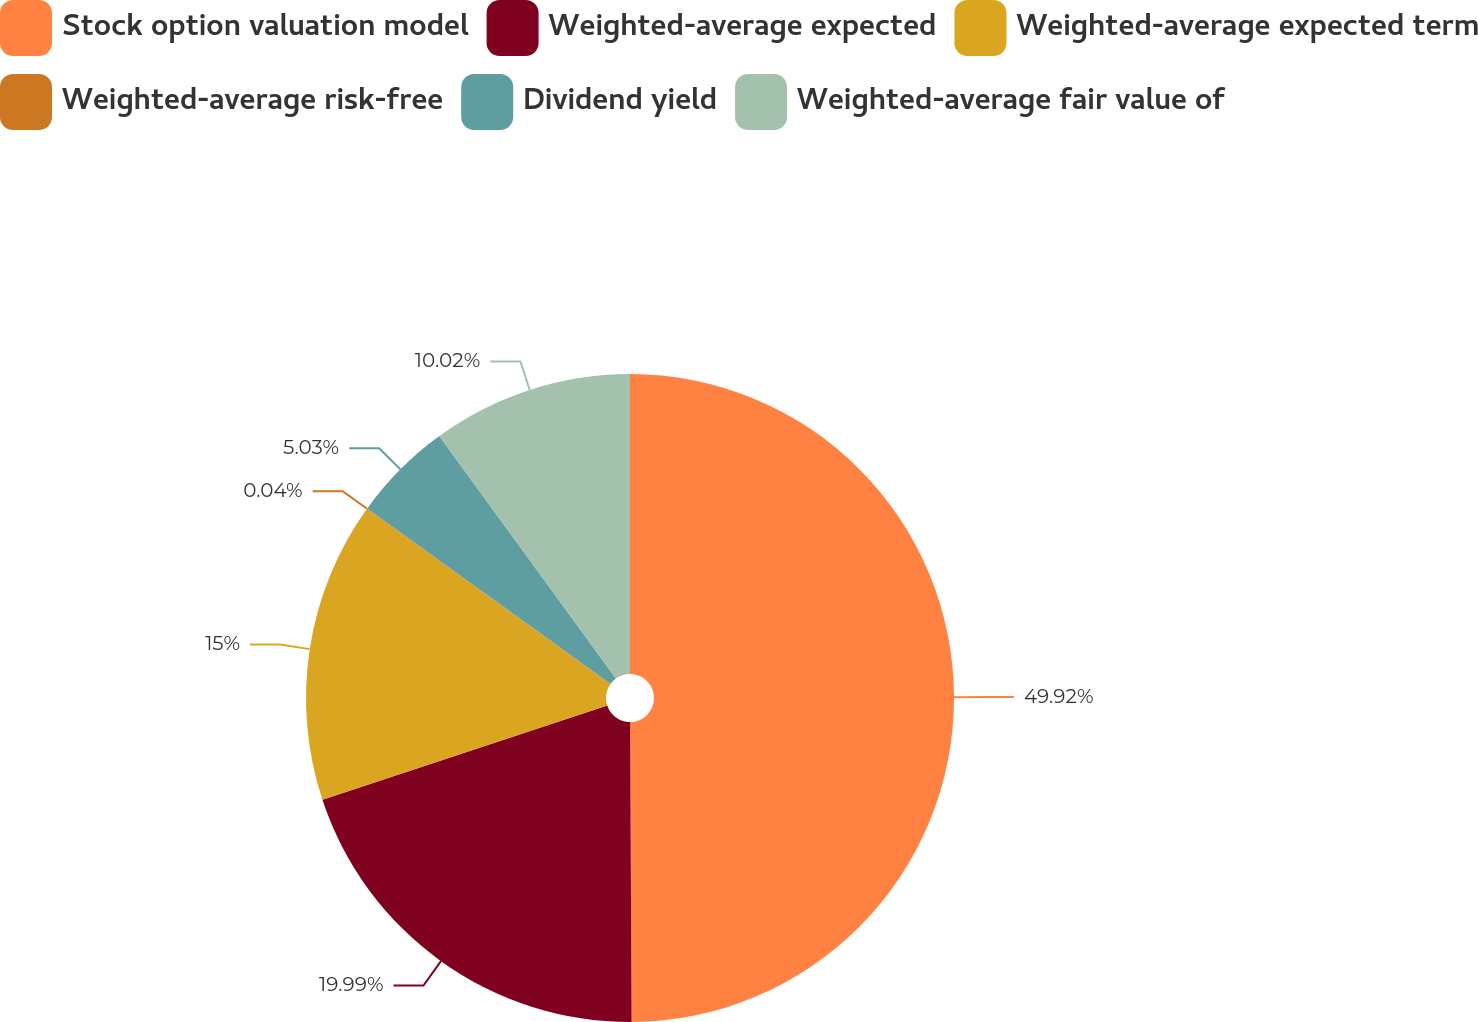Convert chart to OTSL. <chart><loc_0><loc_0><loc_500><loc_500><pie_chart><fcel>Stock option valuation model<fcel>Weighted-average expected<fcel>Weighted-average expected term<fcel>Weighted-average risk-free<fcel>Dividend yield<fcel>Weighted-average fair value of<nl><fcel>49.92%<fcel>19.99%<fcel>15.0%<fcel>0.04%<fcel>5.03%<fcel>10.02%<nl></chart> 